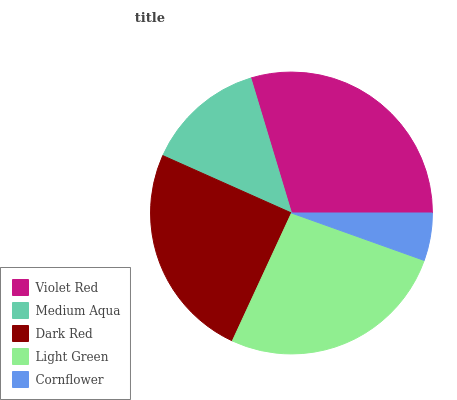Is Cornflower the minimum?
Answer yes or no. Yes. Is Violet Red the maximum?
Answer yes or no. Yes. Is Medium Aqua the minimum?
Answer yes or no. No. Is Medium Aqua the maximum?
Answer yes or no. No. Is Violet Red greater than Medium Aqua?
Answer yes or no. Yes. Is Medium Aqua less than Violet Red?
Answer yes or no. Yes. Is Medium Aqua greater than Violet Red?
Answer yes or no. No. Is Violet Red less than Medium Aqua?
Answer yes or no. No. Is Dark Red the high median?
Answer yes or no. Yes. Is Dark Red the low median?
Answer yes or no. Yes. Is Light Green the high median?
Answer yes or no. No. Is Light Green the low median?
Answer yes or no. No. 